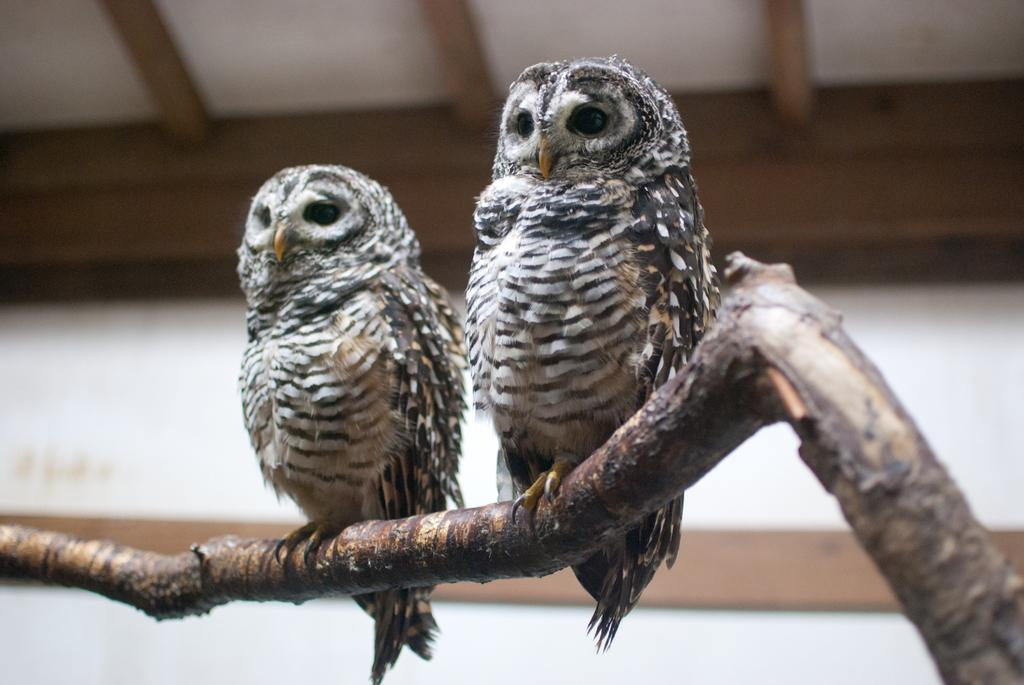How many owls are depicted in the image? There are two owls in the image. What are the owls standing on? The owls are standing on a branch. Can you describe the coloring of the owls? The owls have brown, black, and white coloring. What can be observed about the background of the image? The background of the image is blurred. What type of boat is visible in the image? There is no boat present in the image; it features two owls standing on a branch. How does the war affect the owls in the image? There is no war depicted in the image, and therefore no impact on the owls can be observed. 